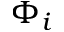Convert formula to latex. <formula><loc_0><loc_0><loc_500><loc_500>\Phi _ { i }</formula> 